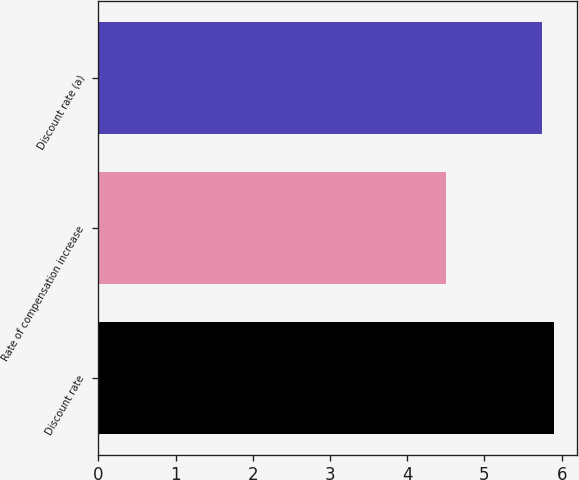Convert chart to OTSL. <chart><loc_0><loc_0><loc_500><loc_500><bar_chart><fcel>Discount rate<fcel>Rate of compensation increase<fcel>Discount rate (a)<nl><fcel>5.9<fcel>4.5<fcel>5.75<nl></chart> 